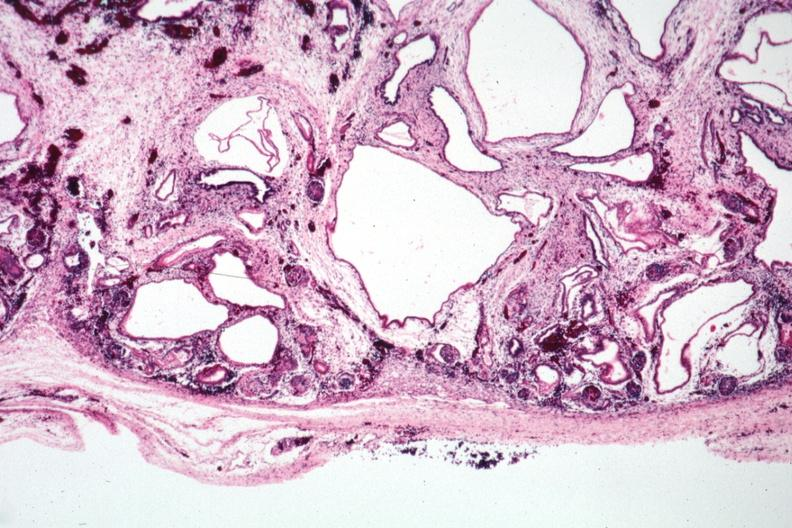s polycystic disease infant present?
Answer the question using a single word or phrase. Yes 